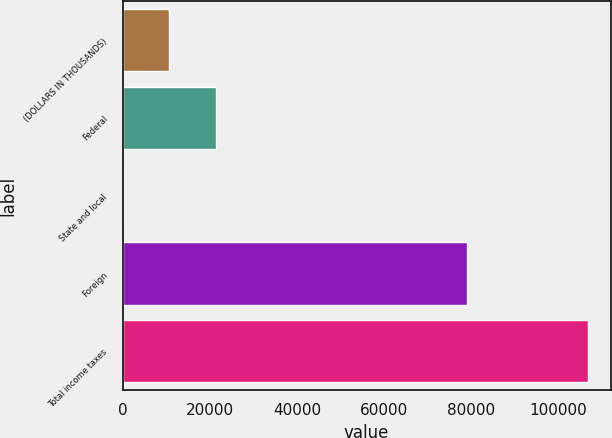Convert chart to OTSL. <chart><loc_0><loc_0><loc_500><loc_500><bar_chart><fcel>(DOLLARS IN THOUSANDS)<fcel>Federal<fcel>State and local<fcel>Foreign<fcel>Total income taxes<nl><fcel>10681.5<fcel>21348<fcel>15<fcel>78922<fcel>106680<nl></chart> 